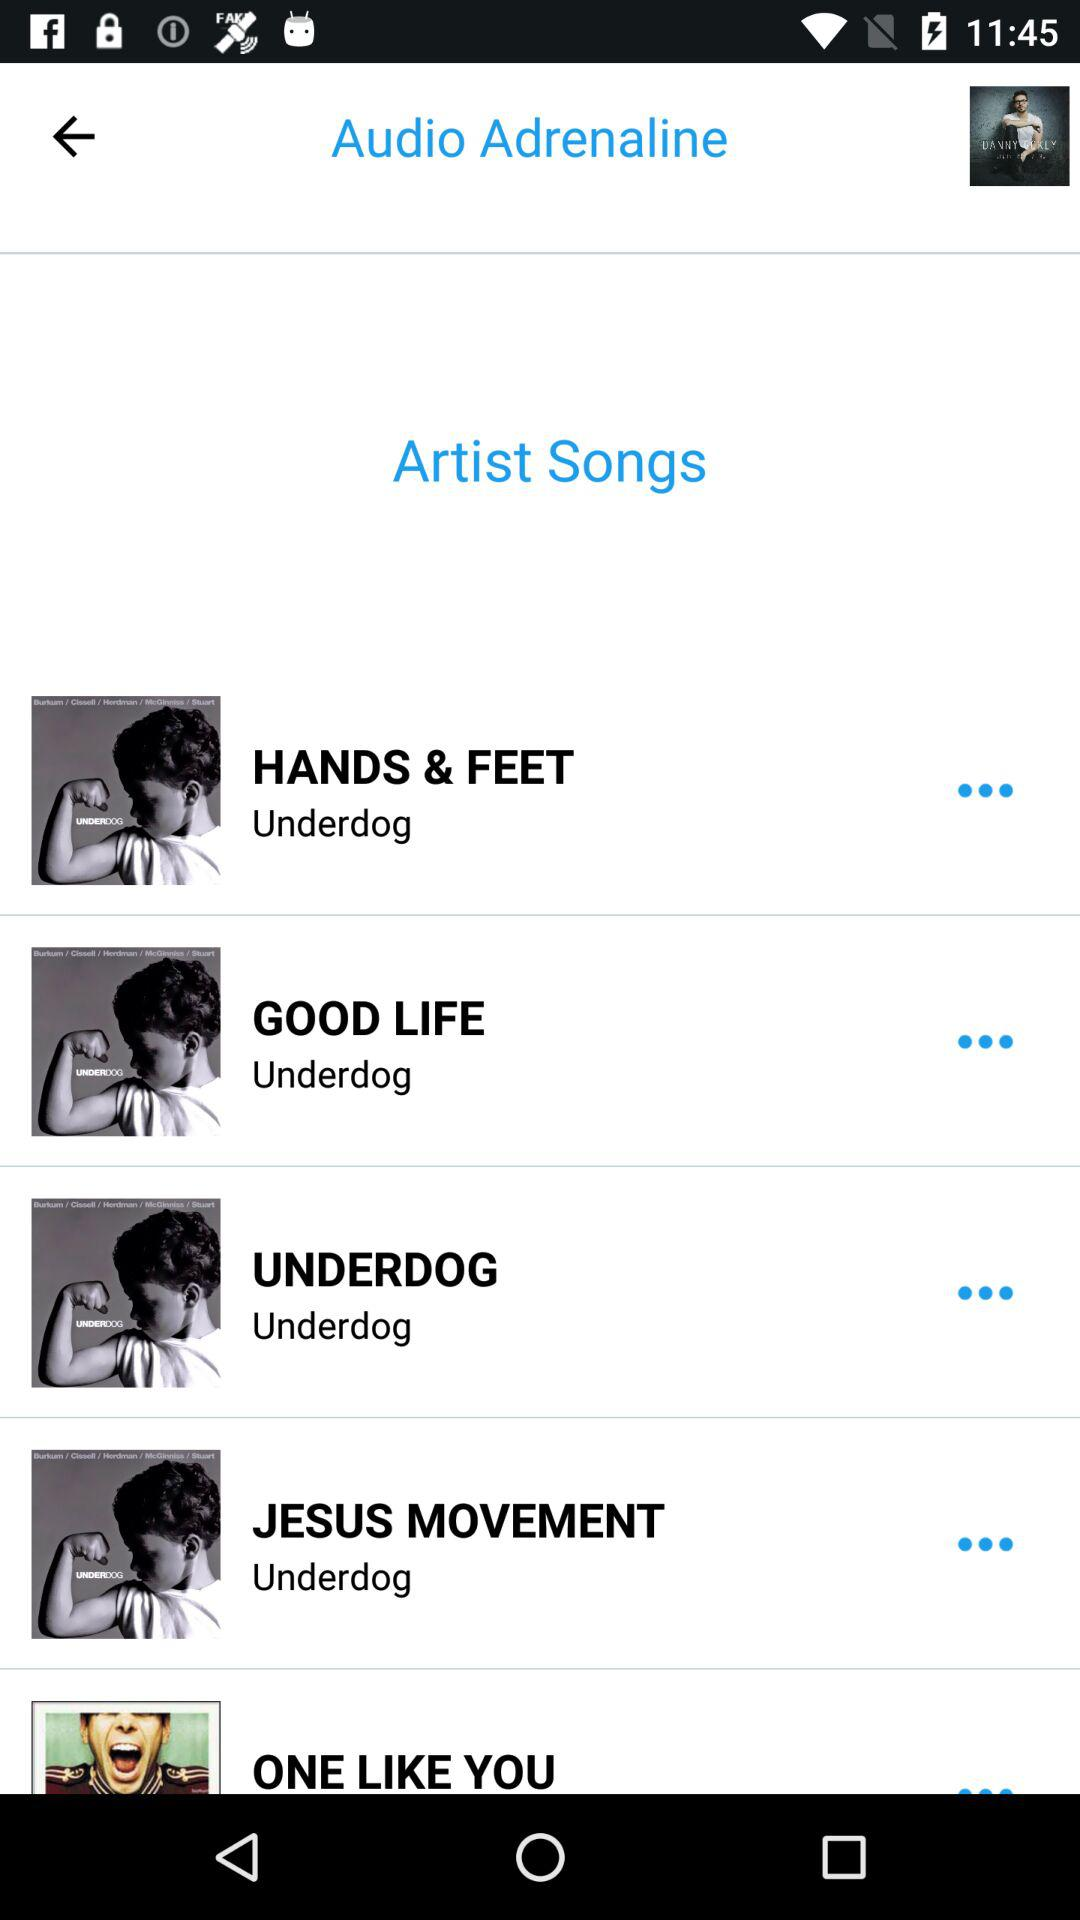Who sang the song "HANDS & FEET"? The song "HANDS & FEET" was sung by "Audio Adrenaline". 